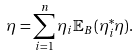Convert formula to latex. <formula><loc_0><loc_0><loc_500><loc_500>\eta = \sum _ { i = 1 } ^ { n } \eta _ { i } { \mathbb { E } } _ { B } ( \eta _ { i } ^ { * } \eta ) .</formula> 